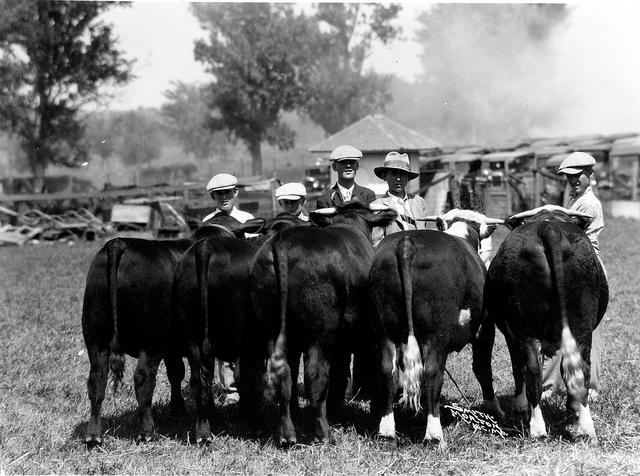Are all the people in this picture wearing hats?
Answer briefly. Yes. How many hind legs are in this picture?
Quick response, please. 10. Are all of the animals the same color?
Concise answer only. Yes. How many bulls are there?
Answer briefly. 5. Is this a current era photo?
Short answer required. No. Are these milk cows ready to be milked?
Keep it brief. No. 